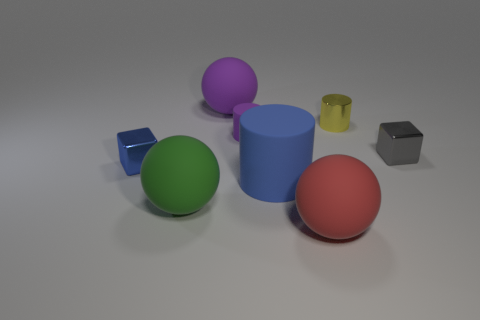Is the number of tiny metallic blocks in front of the tiny purple matte thing greater than the number of blue metallic blocks?
Ensure brevity in your answer.  Yes. What is the color of the big sphere to the left of the big object behind the yellow metallic thing that is in front of the large purple ball?
Offer a terse response. Green. Do the big red object and the tiny gray object have the same material?
Your answer should be very brief. No. Are there any red objects of the same size as the green rubber thing?
Offer a terse response. Yes. There is a gray object that is the same size as the metallic cylinder; what is its material?
Ensure brevity in your answer.  Metal. Is there a purple matte thing that has the same shape as the big green rubber object?
Provide a succinct answer. Yes. What material is the cube that is the same color as the big matte cylinder?
Keep it short and to the point. Metal. What is the shape of the object in front of the big green object?
Give a very brief answer. Sphere. How many small gray cubes are there?
Give a very brief answer. 1. There is a small object that is made of the same material as the blue cylinder; what is its color?
Ensure brevity in your answer.  Purple. 